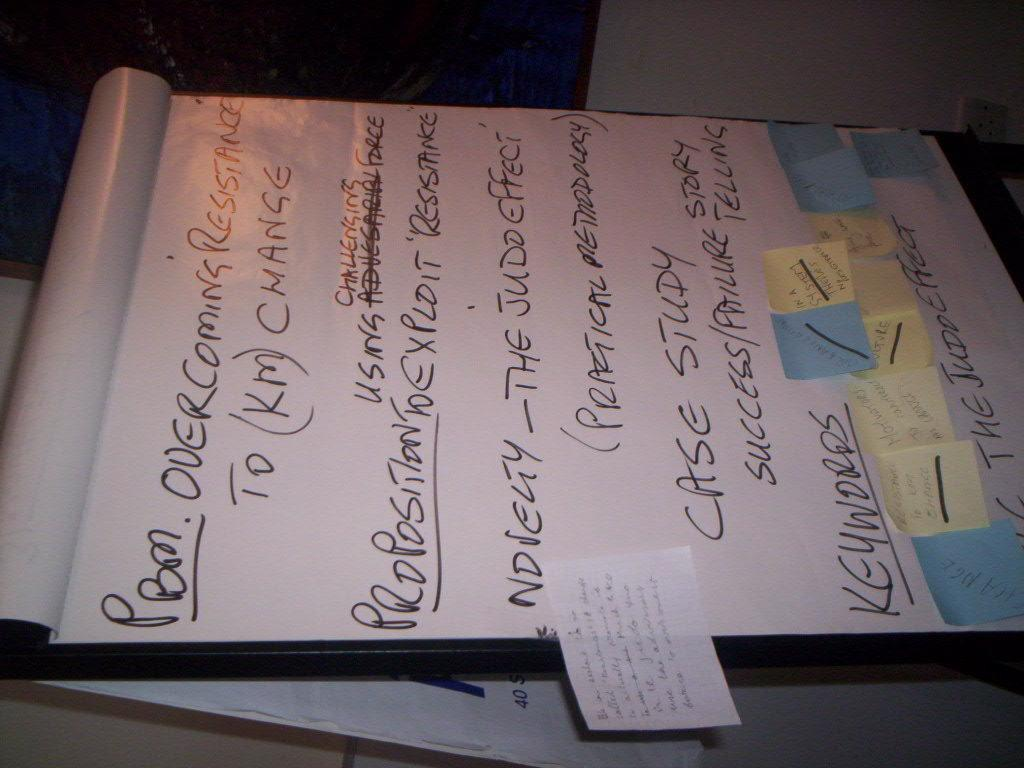<image>
Provide a brief description of the given image. A whiteboard displays a section titled Proposition and another called Keywords. 